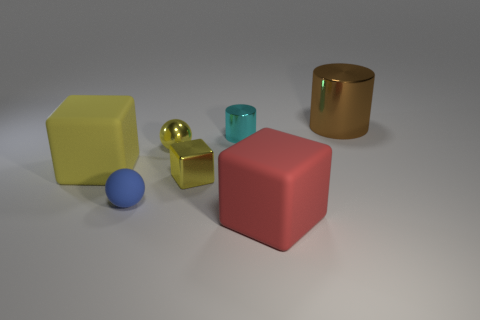How many purple rubber things have the same shape as the tiny blue matte thing?
Give a very brief answer. 0. Does the big matte block that is behind the tiny blue sphere have the same color as the tiny block that is on the right side of the blue matte sphere?
Your answer should be compact. Yes. How many things are either small metallic spheres or yellow objects?
Provide a short and direct response. 3. What number of large cylinders are the same material as the large yellow block?
Offer a terse response. 0. Is the number of balls less than the number of yellow objects?
Your answer should be compact. Yes. Are the block that is in front of the metallic cube and the small cyan thing made of the same material?
Your answer should be compact. No. What number of blocks are big red objects or small objects?
Keep it short and to the point. 2. The thing that is both left of the big red cube and on the right side of the tiny block has what shape?
Your answer should be very brief. Cylinder. There is a metallic cylinder on the left side of the metallic cylinder right of the large matte thing that is right of the small blue thing; what color is it?
Provide a succinct answer. Cyan. Is the number of blue rubber balls that are in front of the small yellow cube less than the number of big blue metallic blocks?
Offer a terse response. No. 